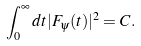<formula> <loc_0><loc_0><loc_500><loc_500>\int _ { 0 } ^ { \infty } d t | F _ { \psi } ( t ) | ^ { 2 } = C .</formula> 